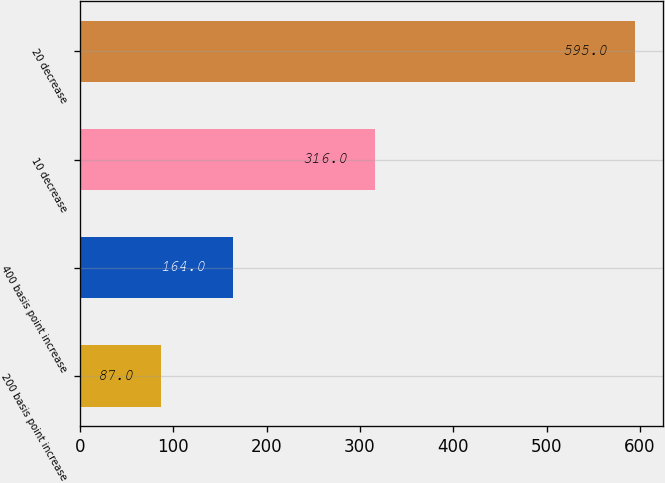Convert chart. <chart><loc_0><loc_0><loc_500><loc_500><bar_chart><fcel>200 basis point increase<fcel>400 basis point increase<fcel>10 decrease<fcel>20 decrease<nl><fcel>87<fcel>164<fcel>316<fcel>595<nl></chart> 